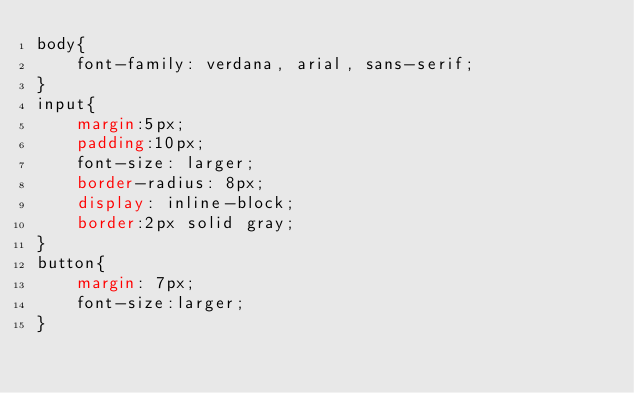Convert code to text. <code><loc_0><loc_0><loc_500><loc_500><_CSS_>body{
    font-family: verdana, arial, sans-serif;
}
input{
    margin:5px;
    padding:10px;
    font-size: larger;
    border-radius: 8px;
    display: inline-block;
    border:2px solid gray;
}
button{
    margin: 7px;
    font-size:larger;
}
</code> 